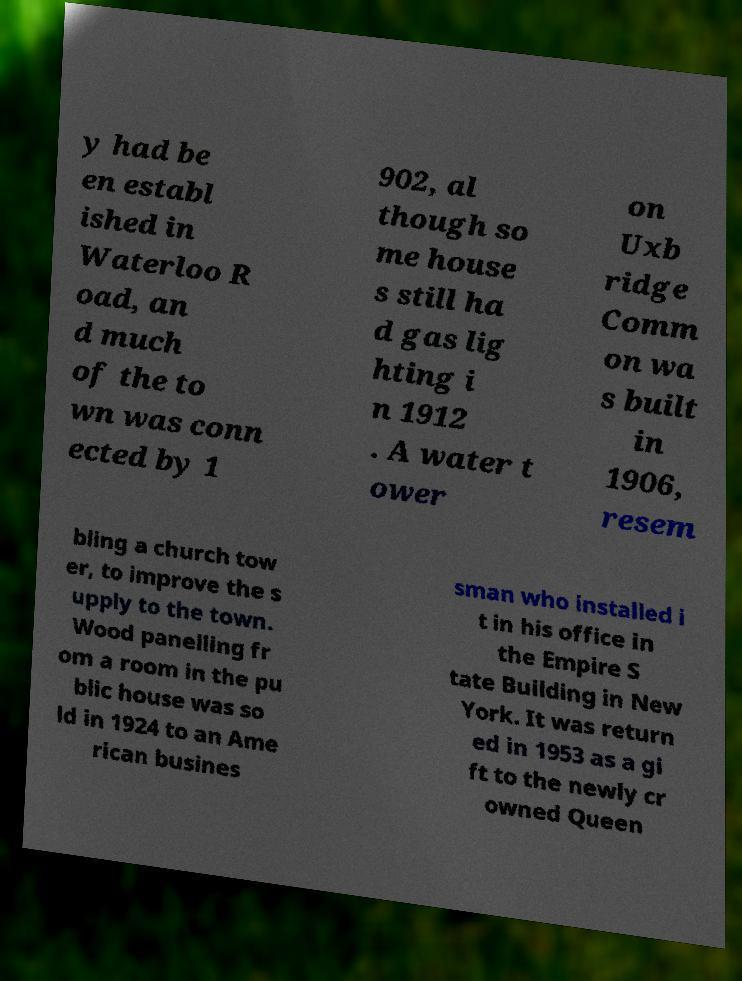Please read and relay the text visible in this image. What does it say? y had be en establ ished in Waterloo R oad, an d much of the to wn was conn ected by 1 902, al though so me house s still ha d gas lig hting i n 1912 . A water t ower on Uxb ridge Comm on wa s built in 1906, resem bling a church tow er, to improve the s upply to the town. Wood panelling fr om a room in the pu blic house was so ld in 1924 to an Ame rican busines sman who installed i t in his office in the Empire S tate Building in New York. It was return ed in 1953 as a gi ft to the newly cr owned Queen 